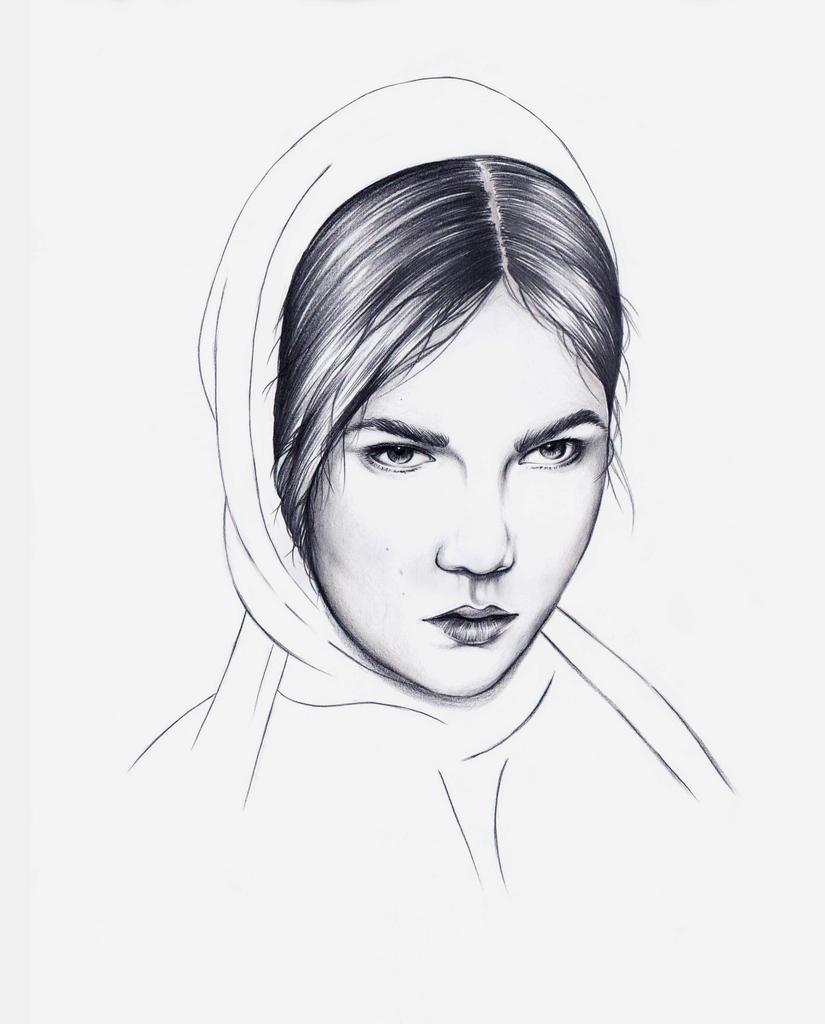What is the main subject of the image? There is an artwork in the image. What does the artwork depict? The artwork depicts a woman. What color scheme is used in the artwork? The artwork is in black and white colors. What is the background color of the artwork? The artwork is on a white-colored surface. How many leaves are present in the artwork? There are no leaves depicted in the artwork, as it is a black and white image of a woman. 